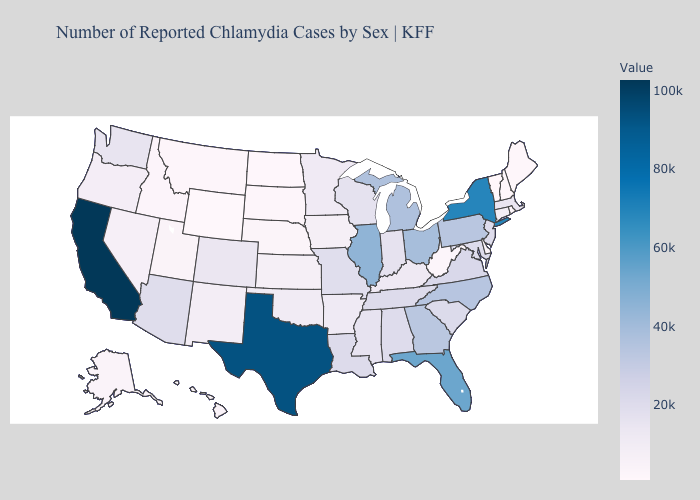Which states hav the highest value in the Northeast?
Answer briefly. New York. Does Indiana have a lower value than Georgia?
Short answer required. Yes. Among the states that border Idaho , which have the lowest value?
Short answer required. Wyoming. Does Washington have a higher value than Illinois?
Concise answer only. No. Among the states that border Massachusetts , does Connecticut have the highest value?
Give a very brief answer. No. 